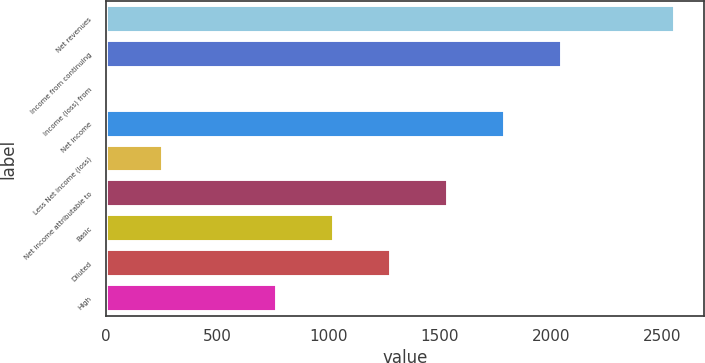Convert chart. <chart><loc_0><loc_0><loc_500><loc_500><bar_chart><fcel>Net revenues<fcel>Income from continuing<fcel>Income (loss) from<fcel>Net income<fcel>Less Net income (loss)<fcel>Net income attributable to<fcel>Basic<fcel>Diluted<fcel>High<nl><fcel>2561<fcel>2049<fcel>1<fcel>1793<fcel>257<fcel>1537<fcel>1025<fcel>1281<fcel>769<nl></chart> 